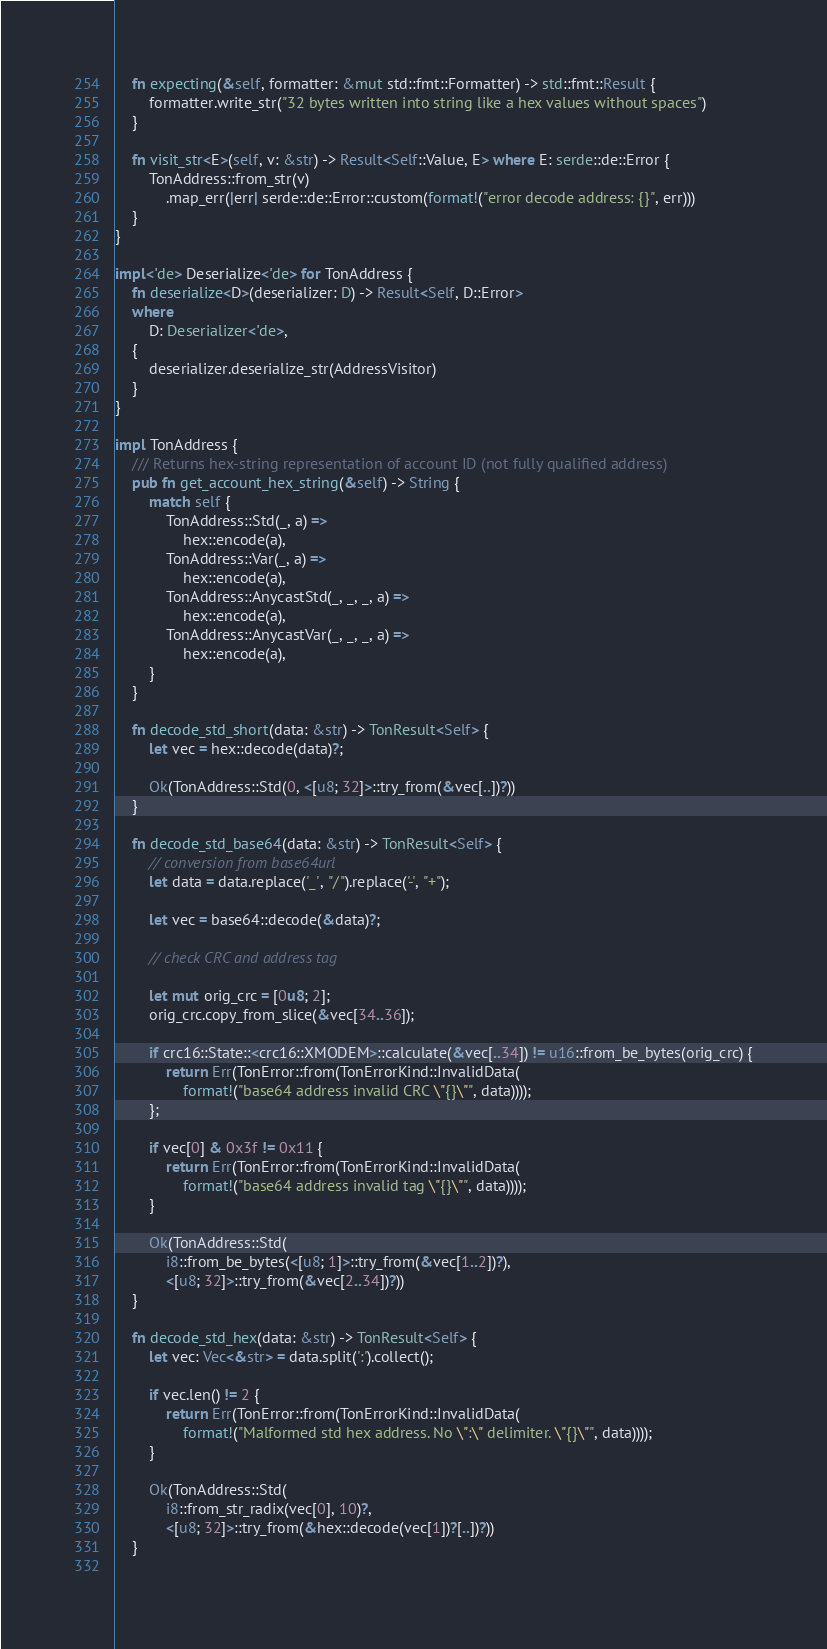<code> <loc_0><loc_0><loc_500><loc_500><_Rust_>
    fn expecting(&self, formatter: &mut std::fmt::Formatter) -> std::fmt::Result {
        formatter.write_str("32 bytes written into string like a hex values without spaces")
    }

    fn visit_str<E>(self, v: &str) -> Result<Self::Value, E> where E: serde::de::Error {
        TonAddress::from_str(v)
            .map_err(|err| serde::de::Error::custom(format!("error decode address: {}", err)))
    }
}

impl<'de> Deserialize<'de> for TonAddress {
    fn deserialize<D>(deserializer: D) -> Result<Self, D::Error>
    where
        D: Deserializer<'de>, 
    {
        deserializer.deserialize_str(AddressVisitor)
    }
}

impl TonAddress {
    /// Returns hex-string representation of account ID (not fully qualified address)
    pub fn get_account_hex_string(&self) -> String {
        match self {
            TonAddress::Std(_, a) =>
                hex::encode(a),
            TonAddress::Var(_, a) =>
                hex::encode(a),
            TonAddress::AnycastStd(_, _, _, a) =>
                hex::encode(a),
            TonAddress::AnycastVar(_, _, _, a) =>
                hex::encode(a),
        }
    }

    fn decode_std_short(data: &str) -> TonResult<Self> {
        let vec = hex::decode(data)?;

        Ok(TonAddress::Std(0, <[u8; 32]>::try_from(&vec[..])?))
    }
    
    fn decode_std_base64(data: &str) -> TonResult<Self> {
        // conversion from base64url
        let data = data.replace('_', "/").replace('-', "+");

        let vec = base64::decode(&data)?;

        // check CRC and address tag

        let mut orig_crc = [0u8; 2];
        orig_crc.copy_from_slice(&vec[34..36]);

        if crc16::State::<crc16::XMODEM>::calculate(&vec[..34]) != u16::from_be_bytes(orig_crc) {
            return Err(TonError::from(TonErrorKind::InvalidData(
                format!("base64 address invalid CRC \"{}\"", data))));
        };

        if vec[0] & 0x3f != 0x11 {
            return Err(TonError::from(TonErrorKind::InvalidData(
                format!("base64 address invalid tag \"{}\"", data))));
        }

        Ok(TonAddress::Std(
            i8::from_be_bytes(<[u8; 1]>::try_from(&vec[1..2])?),
            <[u8; 32]>::try_from(&vec[2..34])?))
    }

    fn decode_std_hex(data: &str) -> TonResult<Self> {
        let vec: Vec<&str> = data.split(':').collect();

        if vec.len() != 2 {
            return Err(TonError::from(TonErrorKind::InvalidData(
                format!("Malformed std hex address. No \":\" delimiter. \"{}\"", data))));
        }

        Ok(TonAddress::Std(
            i8::from_str_radix(vec[0], 10)?,
            <[u8; 32]>::try_from(&hex::decode(vec[1])?[..])?))
    }
    </code> 